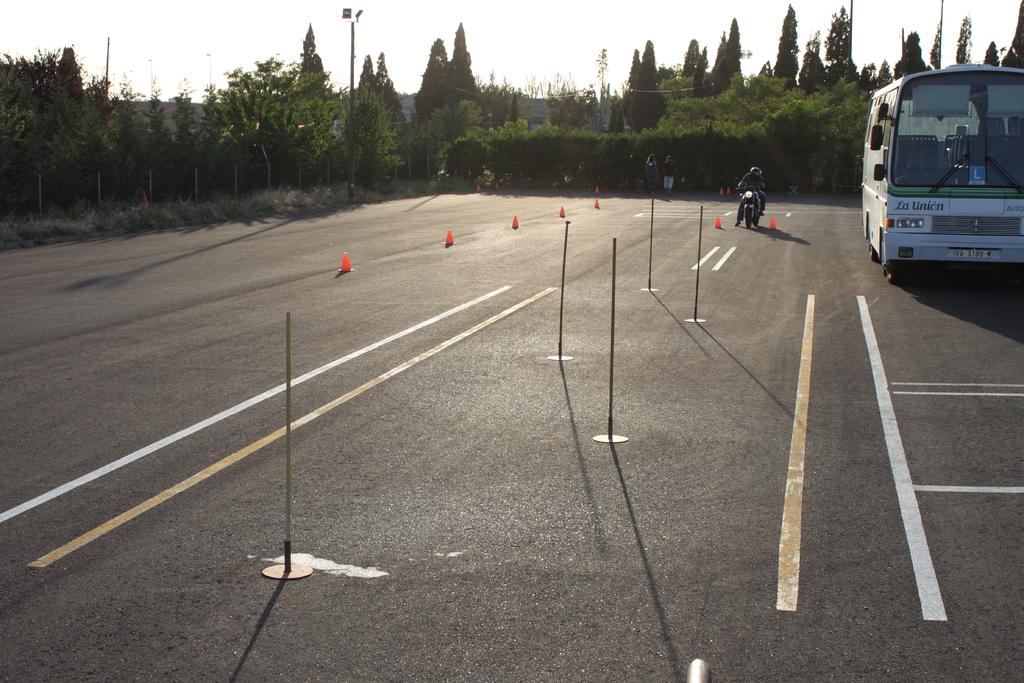What is the main subject of the image? The image shows a view of the road. Can you describe any vehicles in the image? Yes, there is a white bus on the right side of the road. What else can be seen on the road? A bike is parked on the road. What can be seen in the background of the image? There are many trees visible in the background. What is visible at the top of the image? The sky is visible at the top of the image. Can you hear the sound of a hole being dug in the image? There is no sound present in the image, and there is no indication of a hole being dug. Why is the bike crying on the road in the image? Bikes do not have the ability to cry, and there is no indication of any emotional state in the image. 